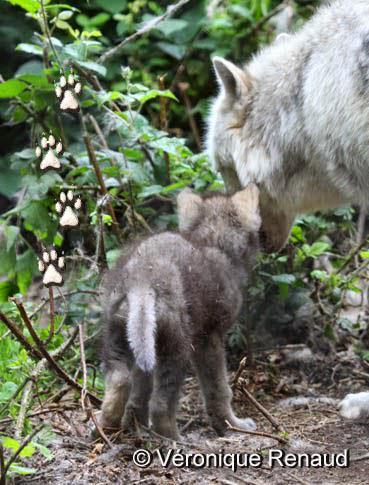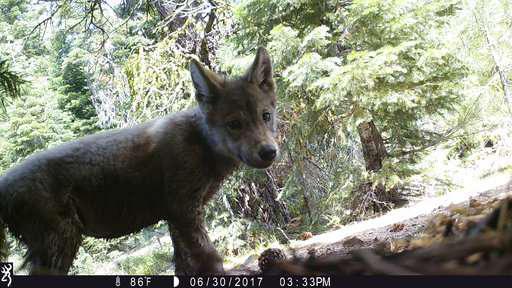The first image is the image on the left, the second image is the image on the right. Assess this claim about the two images: "The right image contains one wolf, a pup standing in front of trees with its body turned rightward.". Correct or not? Answer yes or no. Yes. The first image is the image on the left, the second image is the image on the right. Examine the images to the left and right. Is the description "There are multiple animals in the wild in the image on the left." accurate? Answer yes or no. Yes. 